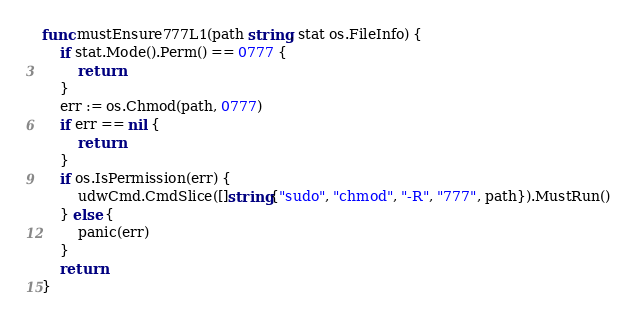<code> <loc_0><loc_0><loc_500><loc_500><_Go_>func mustEnsure777L1(path string, stat os.FileInfo) {
	if stat.Mode().Perm() == 0777 {
		return
	}
	err := os.Chmod(path, 0777)
	if err == nil {
		return
	}
	if os.IsPermission(err) {
		udwCmd.CmdSlice([]string{"sudo", "chmod", "-R", "777", path}).MustRun()
	} else {
		panic(err)
	}
	return
}
</code> 